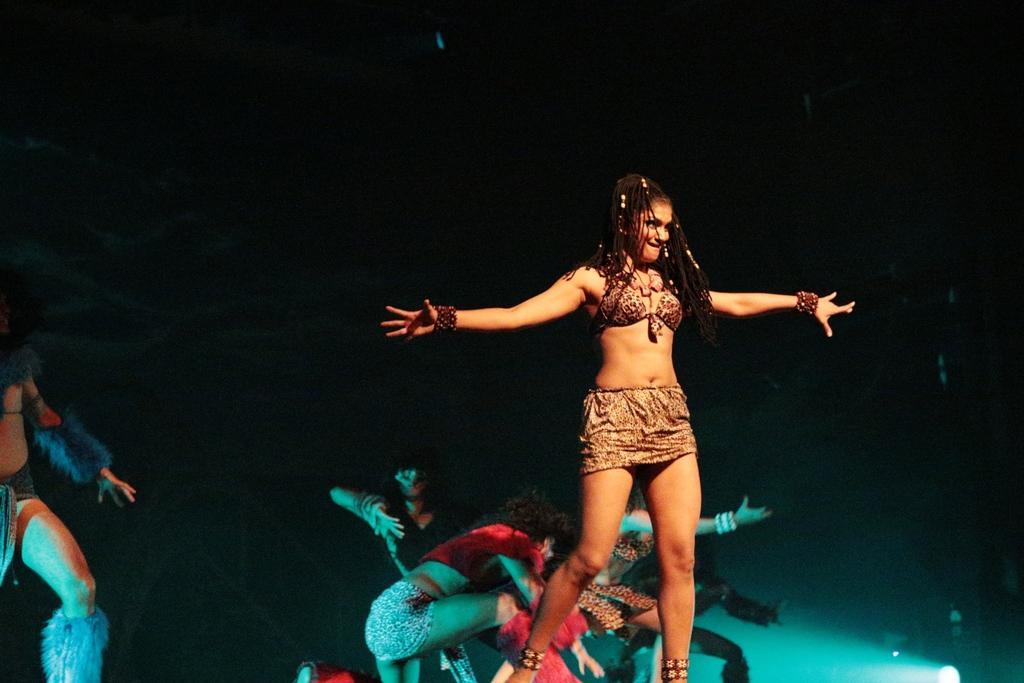How would you summarize this image in a sentence or two? A beautiful woman is dancing, she wore dress. Behind her few other people are also dancing. 